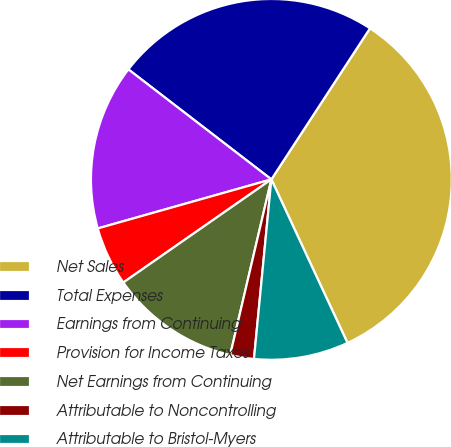Convert chart. <chart><loc_0><loc_0><loc_500><loc_500><pie_chart><fcel>Net Sales<fcel>Total Expenses<fcel>Earnings from Continuing<fcel>Provision for Income Taxes<fcel>Net Earnings from Continuing<fcel>Attributable to Noncontrolling<fcel>Attributable to Bristol-Myers<nl><fcel>33.86%<fcel>23.77%<fcel>14.82%<fcel>5.3%<fcel>11.65%<fcel>2.13%<fcel>8.47%<nl></chart> 